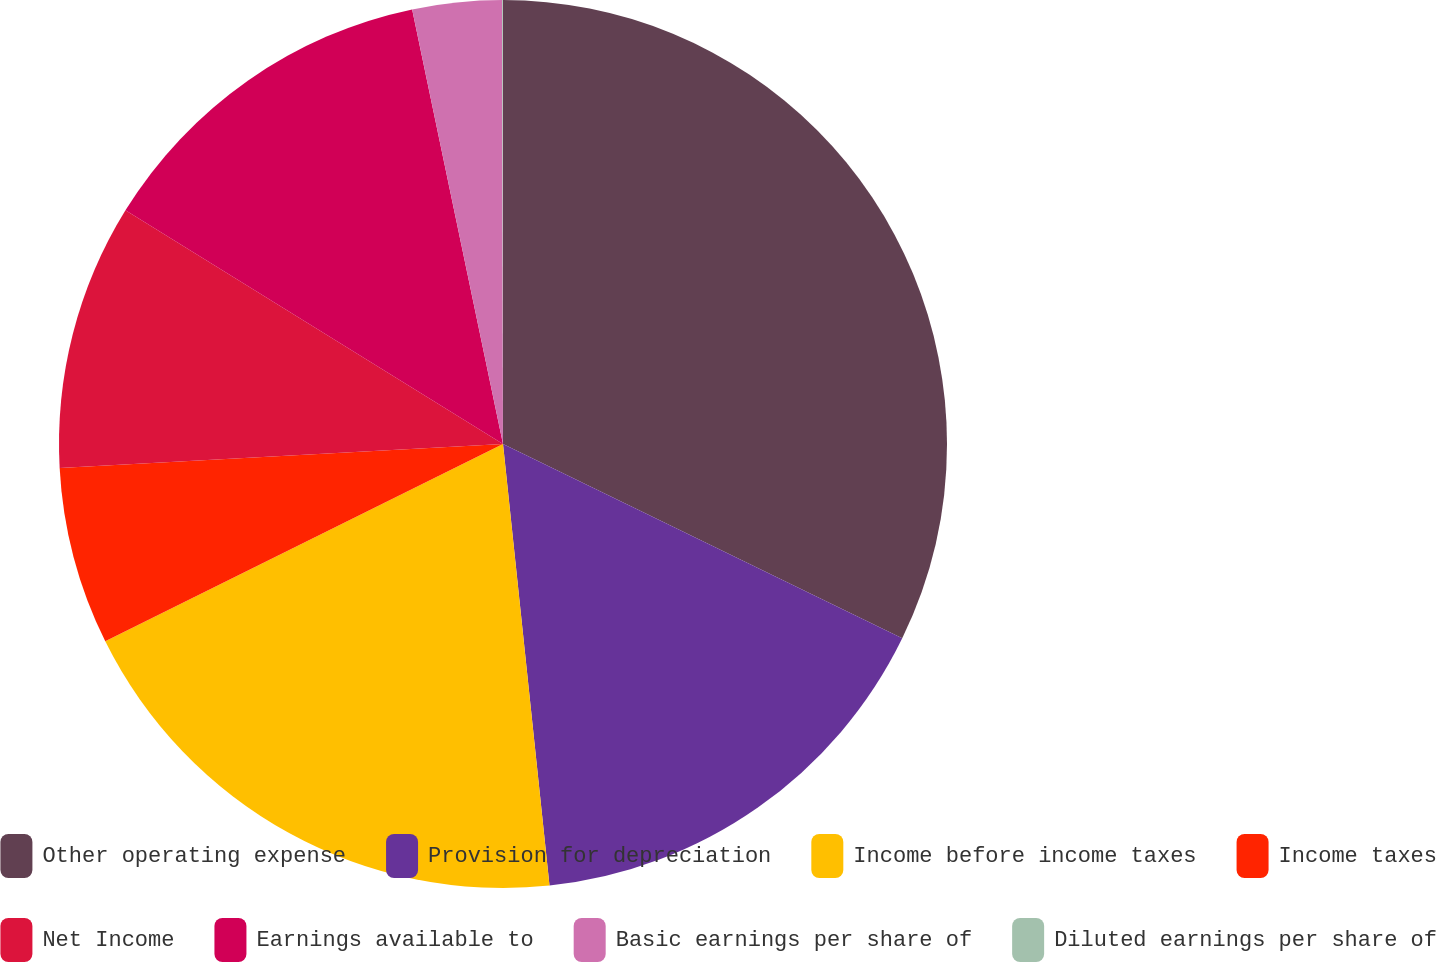<chart> <loc_0><loc_0><loc_500><loc_500><pie_chart><fcel>Other operating expense<fcel>Provision for depreciation<fcel>Income before income taxes<fcel>Income taxes<fcel>Net Income<fcel>Earnings available to<fcel>Basic earnings per share of<fcel>Diluted earnings per share of<nl><fcel>32.21%<fcel>16.12%<fcel>19.34%<fcel>6.47%<fcel>9.68%<fcel>12.9%<fcel>3.25%<fcel>0.03%<nl></chart> 